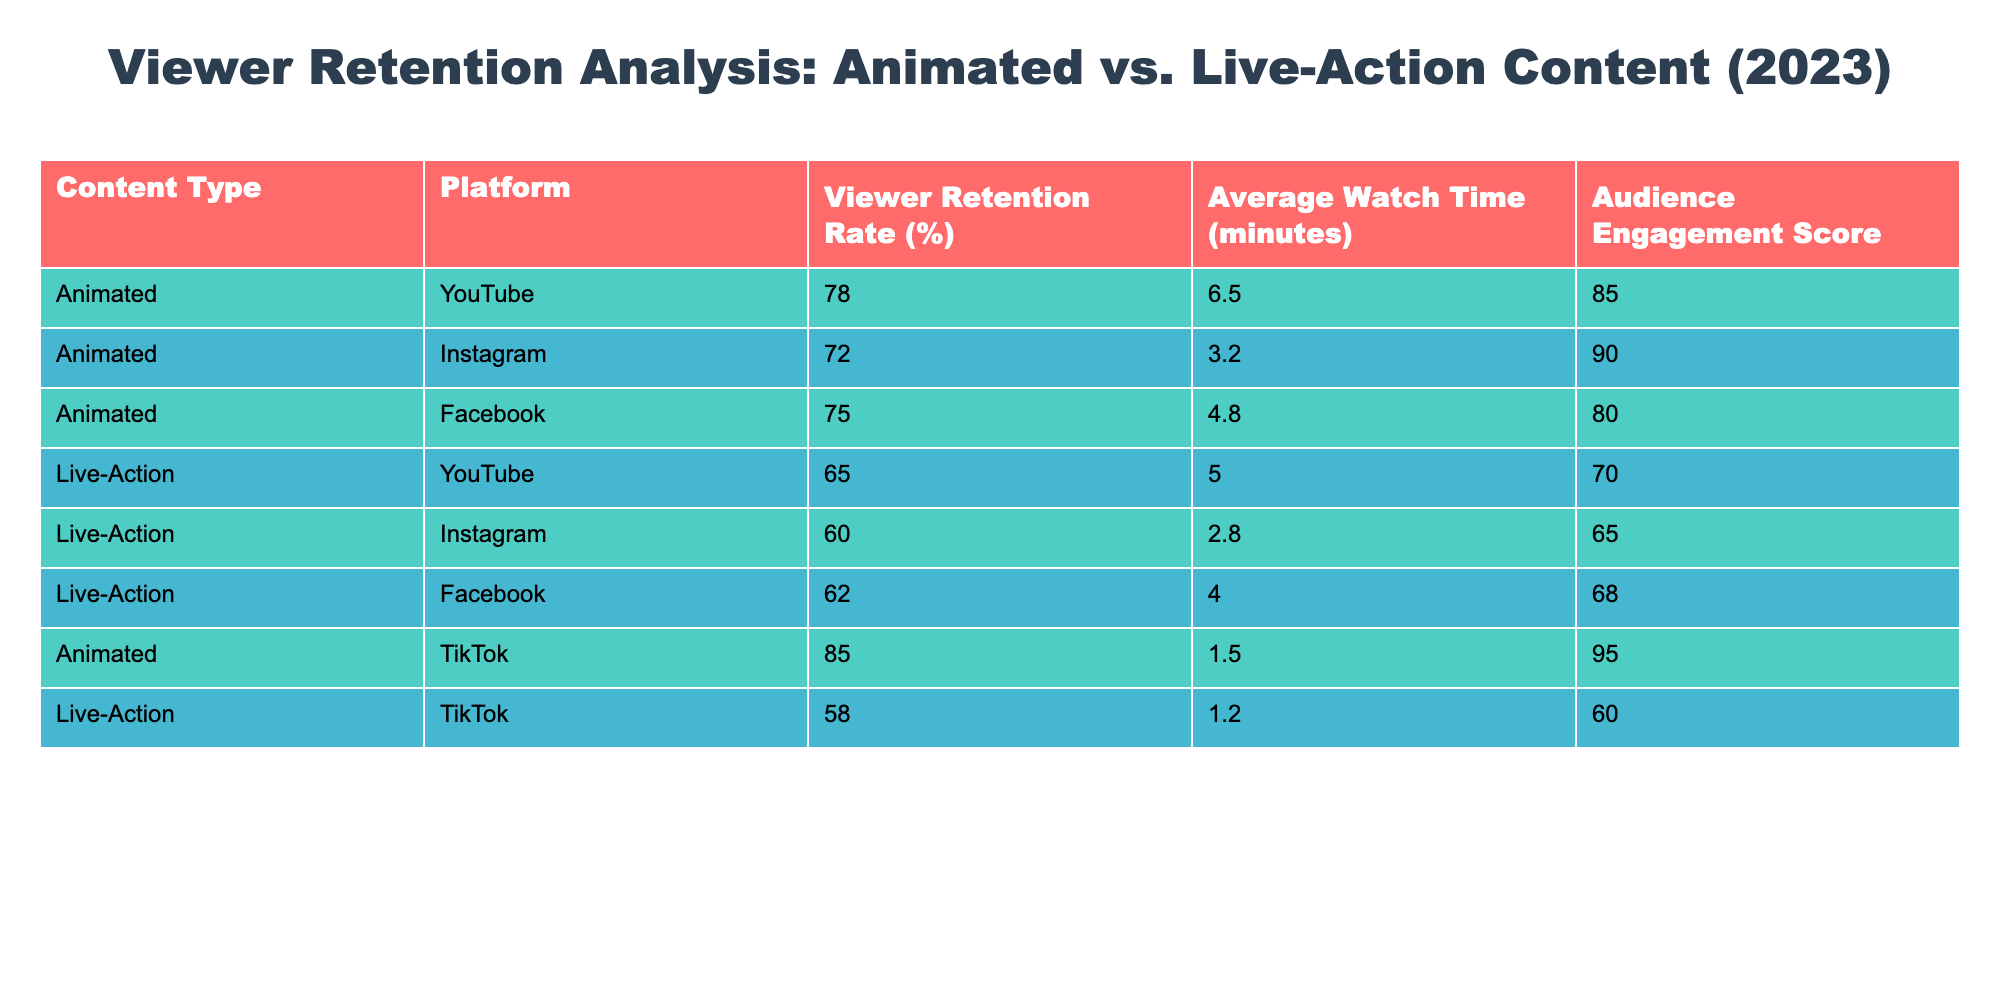What is the viewer retention rate for animated content on YouTube? The viewer retention rate for animated content specifically on YouTube is provided in the table. It is listed as 78%.
Answer: 78% What is the average watch time for live-action content on Facebook? The average watch time for live-action content on Facebook is found in the corresponding cell, which shows 4.0 minutes.
Answer: 4.0 minutes Which content type has a higher average viewer retention rate, animated or live-action? To determine which content type has a higher average viewer retention rate, you need to compare the average viewer retention rates for animated and live-action content. The averages are calculated as follows: Animated - (78 + 72 + 75 + 85) / 4 = 77.5% and Live-Action - (65 + 60 + 62 + 58) / 4 = 61.25%. Hence, animated content has a higher average retention rate.
Answer: Animated content Is the viewer retention rate for animated content on TikTok higher than that for live-action content? The viewer retention rate for animated content on TikTok is 85%, while for live-action content, it is 58%. Since 85% is greater than 58%, the answer is yes, animated content has a higher retention rate.
Answer: Yes What is the difference in audience engagement scores between animated content on Instagram and live-action content on Instagram? To find the difference, look at the audience engagement scores for each content type on Instagram. Animated content has an engagement score of 90, while live-action has 65. The difference is 90 - 65 = 25.
Answer: 25 What is the average watch time for animated content across all platforms? To calculate the average watch time for animated content, sum the average watch times across all platforms where animated content is displayed: (6.5 + 3.2 + 4.8 + 1.5) = 16.0 minutes. Since there are 4 data points, the average is 16.0 / 4 = 4.0 minutes.
Answer: 4.0 minutes Is there any platform where live-action content has a higher viewer retention rate than animated content? By comparing retention rates across the platforms, the highest for animated on YouTube is 78%, while the highest for live-action on the same platform is 65%. For TikTok, animated is 85% and live-action is 58%. In all cases, animated content retains viewers better than live-action; therefore, the answer is no.
Answer: No What is the sum of average watch times for both content types on Instagram? To find the sum of average watch times on Instagram for both content types, add the average watch time for animated content (3.2 minutes) to that for live-action content (2.8 minutes). The sum is 3.2 + 2.8 = 6.0 minutes.
Answer: 6.0 minutes 